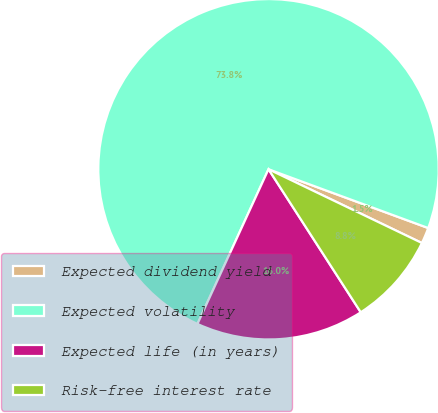Convert chart. <chart><loc_0><loc_0><loc_500><loc_500><pie_chart><fcel>Expected dividend yield<fcel>Expected volatility<fcel>Expected life (in years)<fcel>Risk-free interest rate<nl><fcel>1.52%<fcel>73.76%<fcel>15.97%<fcel>8.75%<nl></chart> 